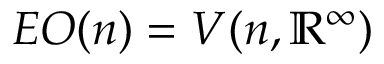<formula> <loc_0><loc_0><loc_500><loc_500>E O ( n ) = V ( n , \mathbb { R } ^ { \infty } )</formula> 